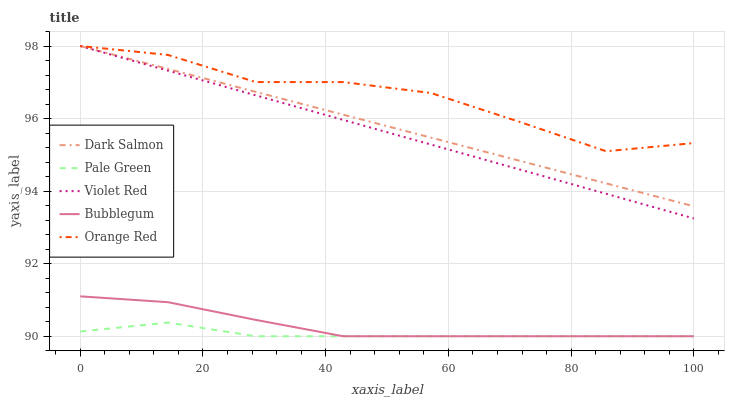Does Pale Green have the minimum area under the curve?
Answer yes or no. Yes. Does Orange Red have the maximum area under the curve?
Answer yes or no. Yes. Does Dark Salmon have the minimum area under the curve?
Answer yes or no. No. Does Dark Salmon have the maximum area under the curve?
Answer yes or no. No. Is Dark Salmon the smoothest?
Answer yes or no. Yes. Is Orange Red the roughest?
Answer yes or no. Yes. Is Pale Green the smoothest?
Answer yes or no. No. Is Pale Green the roughest?
Answer yes or no. No. Does Pale Green have the lowest value?
Answer yes or no. Yes. Does Dark Salmon have the lowest value?
Answer yes or no. No. Does Orange Red have the highest value?
Answer yes or no. Yes. Does Pale Green have the highest value?
Answer yes or no. No. Is Bubblegum less than Orange Red?
Answer yes or no. Yes. Is Orange Red greater than Bubblegum?
Answer yes or no. Yes. Does Violet Red intersect Dark Salmon?
Answer yes or no. Yes. Is Violet Red less than Dark Salmon?
Answer yes or no. No. Is Violet Red greater than Dark Salmon?
Answer yes or no. No. Does Bubblegum intersect Orange Red?
Answer yes or no. No. 